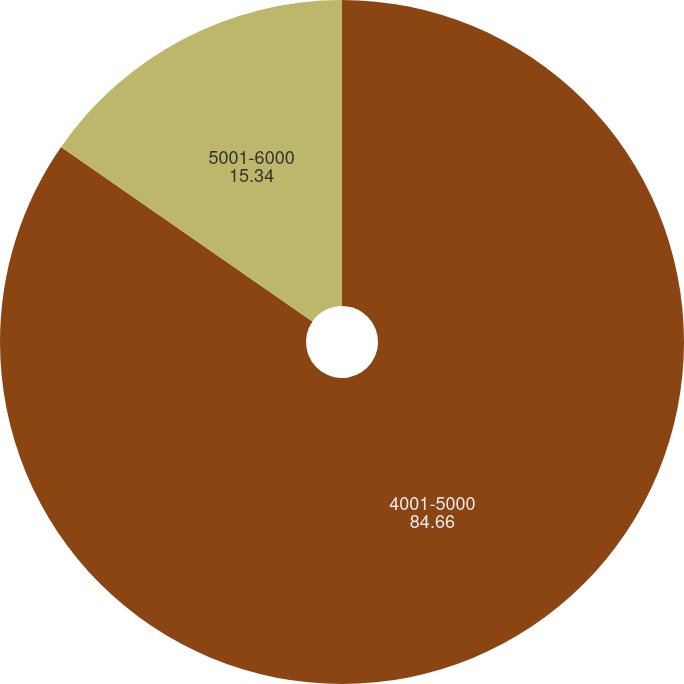Convert chart to OTSL. <chart><loc_0><loc_0><loc_500><loc_500><pie_chart><fcel>4001-5000<fcel>5001-6000<nl><fcel>84.66%<fcel>15.34%<nl></chart> 